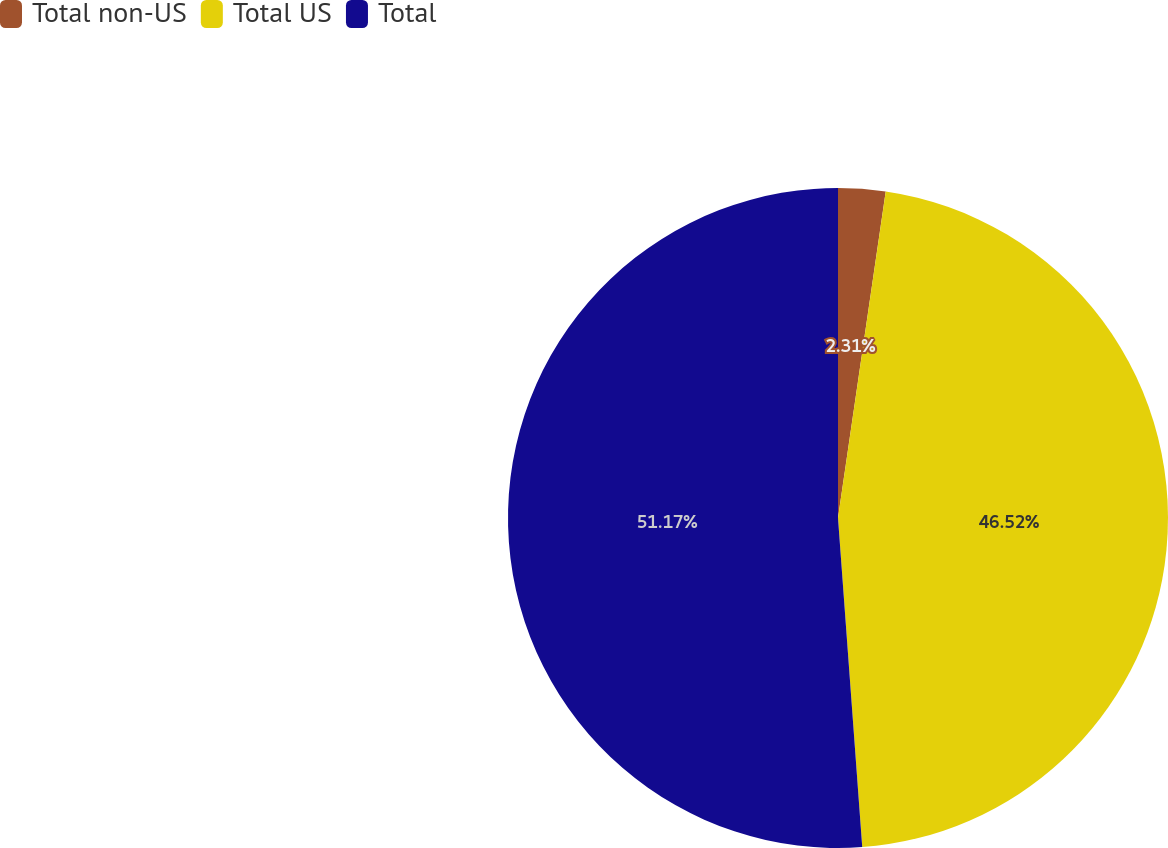Convert chart to OTSL. <chart><loc_0><loc_0><loc_500><loc_500><pie_chart><fcel>Total non-US<fcel>Total US<fcel>Total<nl><fcel>2.31%<fcel>46.52%<fcel>51.17%<nl></chart> 